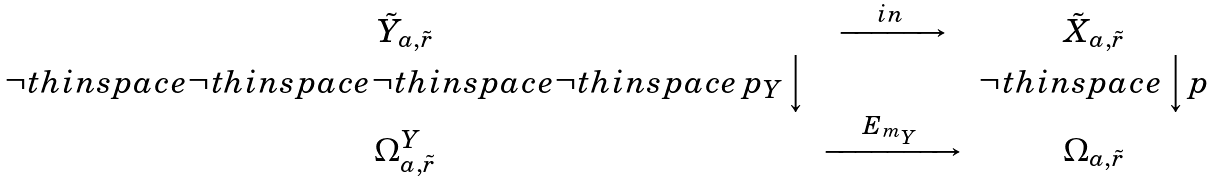<formula> <loc_0><loc_0><loc_500><loc_500>\begin{array} { c c c } \tilde { Y } _ { a , \tilde { r } } & \xrightarrow { \quad i n \quad } & \tilde { X } _ { a , \tilde { r } } \\ \neg t h i n s p a c e \neg t h i n s p a c e \neg t h i n s p a c e \neg t h i n s p a c e \, p _ { Y } \Big \downarrow & & \neg t h i n s p a c e \, \Big \downarrow p \\ \Omega _ { a , \tilde { r } } ^ { Y } & \xrightarrow { \quad E _ { m _ { Y } } \quad } & \Omega _ { a , \tilde { r } } \end{array}</formula> 